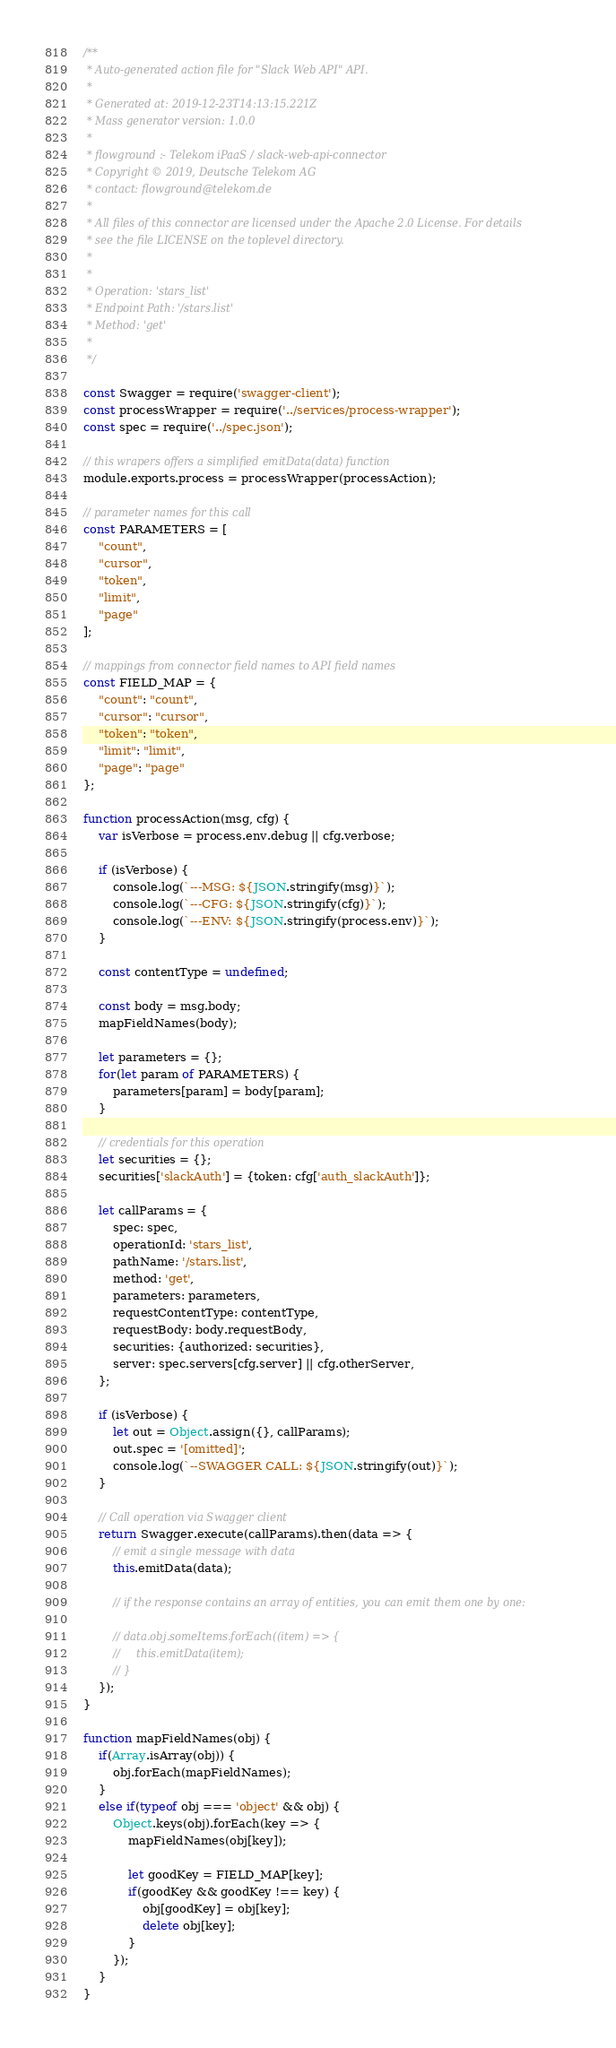<code> <loc_0><loc_0><loc_500><loc_500><_JavaScript_>/**
 * Auto-generated action file for "Slack Web API" API.
 *
 * Generated at: 2019-12-23T14:13:15.221Z
 * Mass generator version: 1.0.0
 *
 * flowground :- Telekom iPaaS / slack-web-api-connector
 * Copyright © 2019, Deutsche Telekom AG
 * contact: flowground@telekom.de
 *
 * All files of this connector are licensed under the Apache 2.0 License. For details
 * see the file LICENSE on the toplevel directory.
 *
 *
 * Operation: 'stars_list'
 * Endpoint Path: '/stars.list'
 * Method: 'get'
 *
 */

const Swagger = require('swagger-client');
const processWrapper = require('../services/process-wrapper');
const spec = require('../spec.json');

// this wrapers offers a simplified emitData(data) function
module.exports.process = processWrapper(processAction);

// parameter names for this call
const PARAMETERS = [
    "count",
    "cursor",
    "token",
    "limit",
    "page"
];

// mappings from connector field names to API field names
const FIELD_MAP = {
    "count": "count",
    "cursor": "cursor",
    "token": "token",
    "limit": "limit",
    "page": "page"
};

function processAction(msg, cfg) {
    var isVerbose = process.env.debug || cfg.verbose;

    if (isVerbose) {
        console.log(`---MSG: ${JSON.stringify(msg)}`);
        console.log(`---CFG: ${JSON.stringify(cfg)}`);
        console.log(`---ENV: ${JSON.stringify(process.env)}`);
    }

    const contentType = undefined;

    const body = msg.body;
    mapFieldNames(body);

    let parameters = {};
    for(let param of PARAMETERS) {
        parameters[param] = body[param];
    }

    // credentials for this operation
    let securities = {};
    securities['slackAuth'] = {token: cfg['auth_slackAuth']};

    let callParams = {
        spec: spec,
        operationId: 'stars_list',
        pathName: '/stars.list',
        method: 'get',
        parameters: parameters,
        requestContentType: contentType,
        requestBody: body.requestBody,
        securities: {authorized: securities},
        server: spec.servers[cfg.server] || cfg.otherServer,
    };

    if (isVerbose) {
        let out = Object.assign({}, callParams);
        out.spec = '[omitted]';
        console.log(`--SWAGGER CALL: ${JSON.stringify(out)}`);
    }

    // Call operation via Swagger client
    return Swagger.execute(callParams).then(data => {
        // emit a single message with data
        this.emitData(data);

        // if the response contains an array of entities, you can emit them one by one:

        // data.obj.someItems.forEach((item) => {
        //     this.emitData(item);
        // }
    });
}

function mapFieldNames(obj) {
    if(Array.isArray(obj)) {
        obj.forEach(mapFieldNames);
    }
    else if(typeof obj === 'object' && obj) {
        Object.keys(obj).forEach(key => {
            mapFieldNames(obj[key]);

            let goodKey = FIELD_MAP[key];
            if(goodKey && goodKey !== key) {
                obj[goodKey] = obj[key];
                delete obj[key];
            }
        });
    }
}</code> 